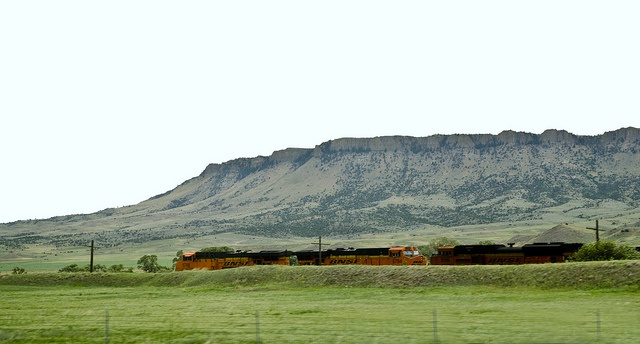Describe the objects in this image and their specific colors. I can see train in white, black, darkgreen, maroon, and gray tones, train in white, black, maroon, and olive tones, and train in white, black, maroon, and olive tones in this image. 